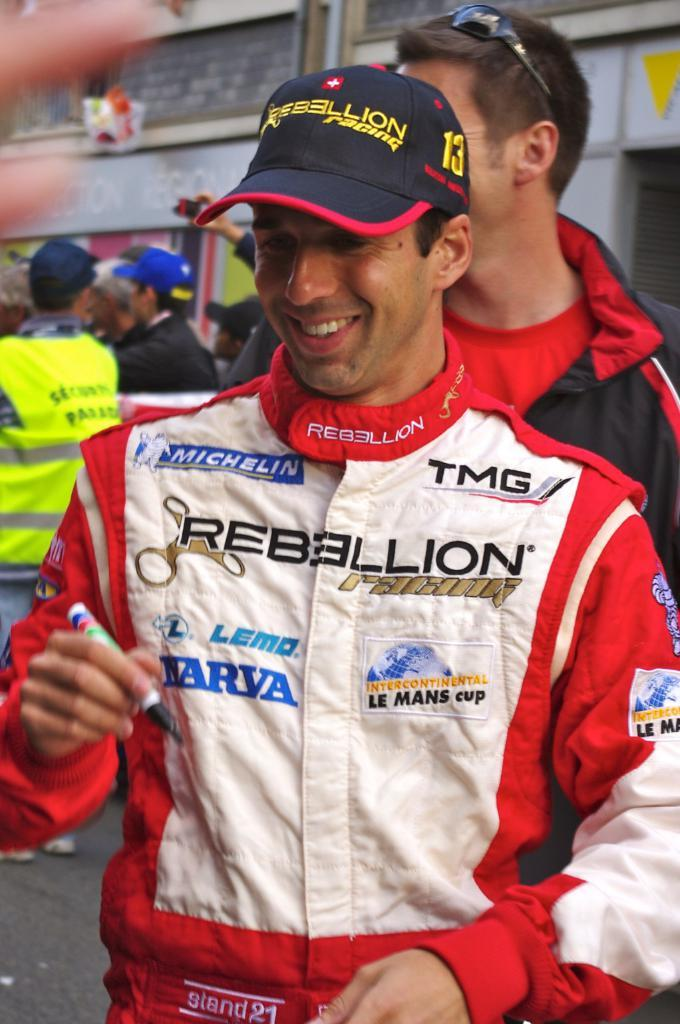What is the person in the front wearing in the image? The person in the front is wearing a red jacket and a black cap in the image. How many other persons are visible in the image? There are other persons standing behind the person in the red jacket in the image. What can be seen in the background of the image? There appears to be a building in the background of the image. What type of men's development can be seen in the image? There is no reference to men's development in the image; it features a person in a red jacket and black cap standing in front of other persons and a building in the background. 